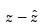Convert formula to latex. <formula><loc_0><loc_0><loc_500><loc_500>z - \hat { z }</formula> 